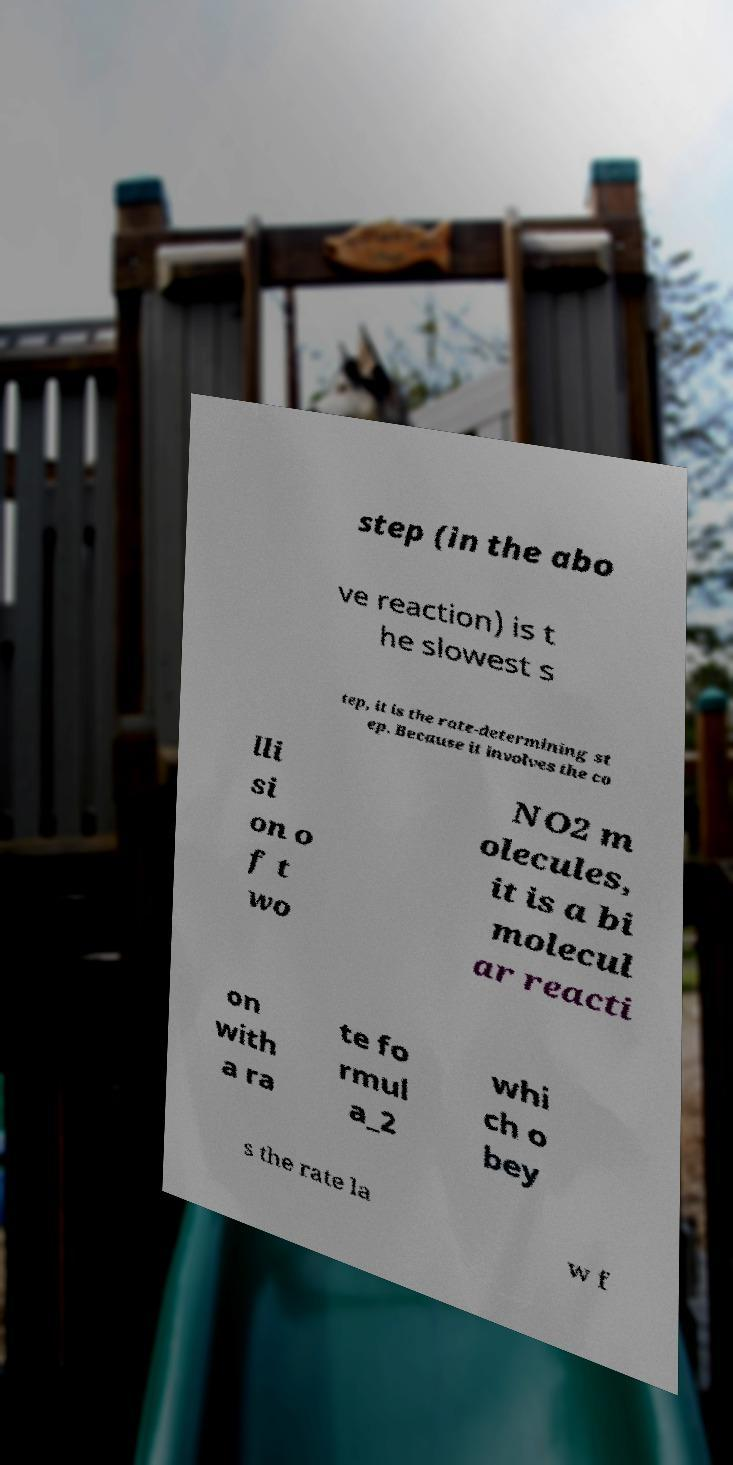Can you accurately transcribe the text from the provided image for me? step (in the abo ve reaction) is t he slowest s tep, it is the rate-determining st ep. Because it involves the co lli si on o f t wo NO2 m olecules, it is a bi molecul ar reacti on with a ra te fo rmul a_2 whi ch o bey s the rate la w f 